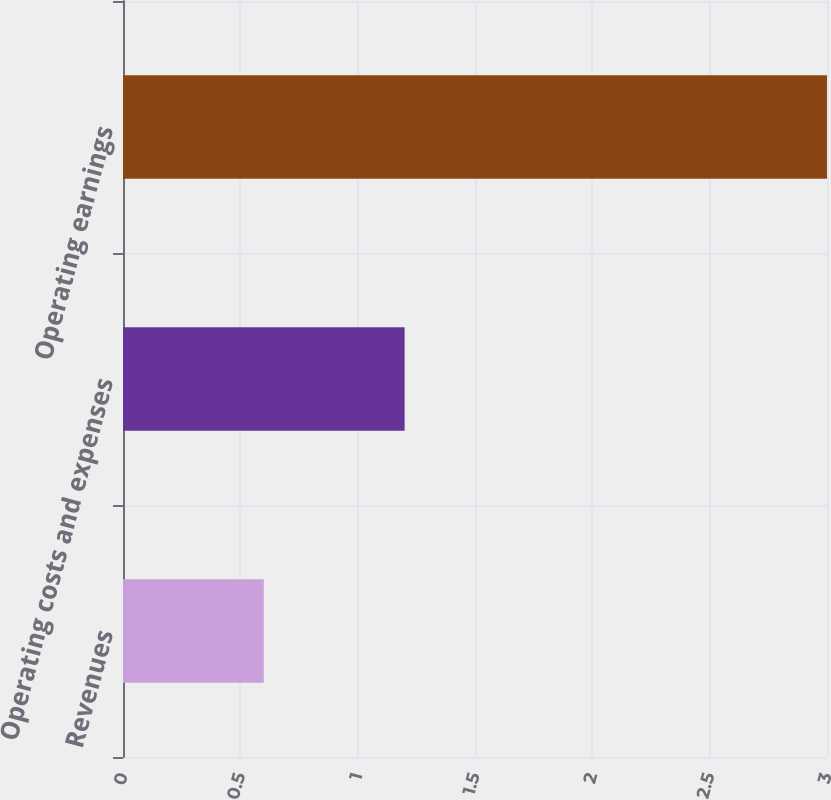<chart> <loc_0><loc_0><loc_500><loc_500><bar_chart><fcel>Revenues<fcel>Operating costs and expenses<fcel>Operating earnings<nl><fcel>0.6<fcel>1.2<fcel>3<nl></chart> 